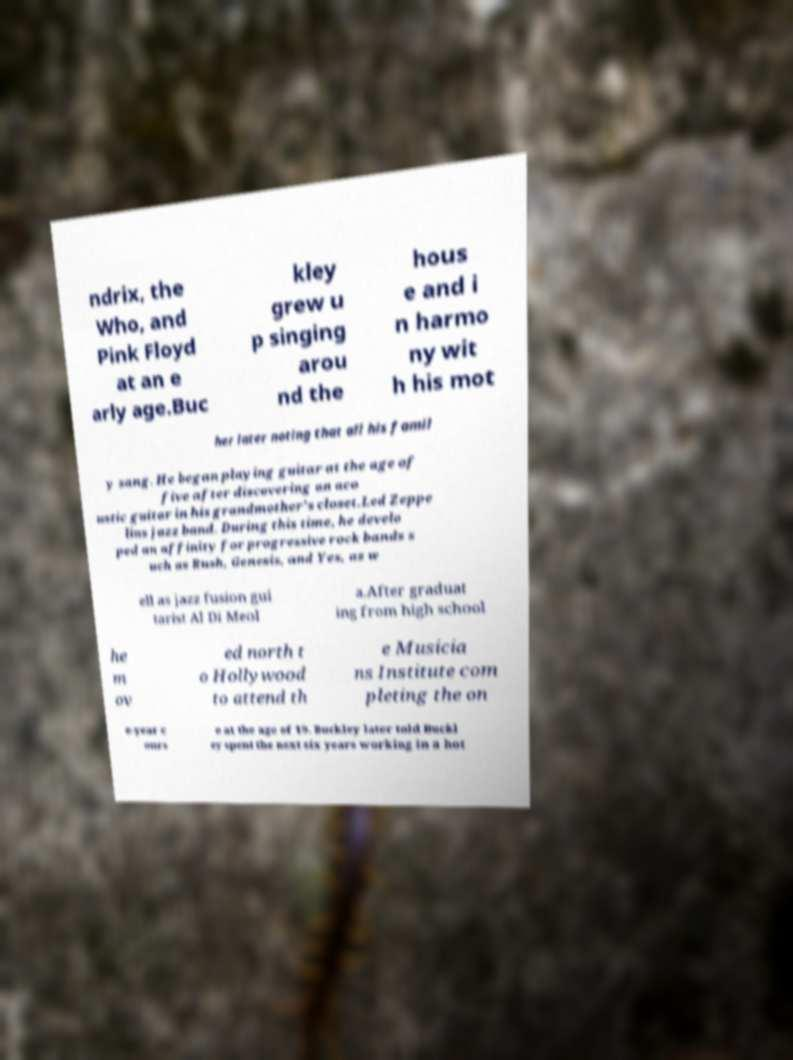Could you assist in decoding the text presented in this image and type it out clearly? ndrix, the Who, and Pink Floyd at an e arly age.Buc kley grew u p singing arou nd the hous e and i n harmo ny wit h his mot her later noting that all his famil y sang. He began playing guitar at the age of five after discovering an aco ustic guitar in his grandmother's closet.Led Zeppe lins jazz band. During this time, he develo ped an affinity for progressive rock bands s uch as Rush, Genesis, and Yes, as w ell as jazz fusion gui tarist Al Di Meol a.After graduat ing from high school he m ov ed north t o Hollywood to attend th e Musicia ns Institute com pleting the on e-year c ours e at the age of 19. Buckley later told Buckl ey spent the next six years working in a hot 